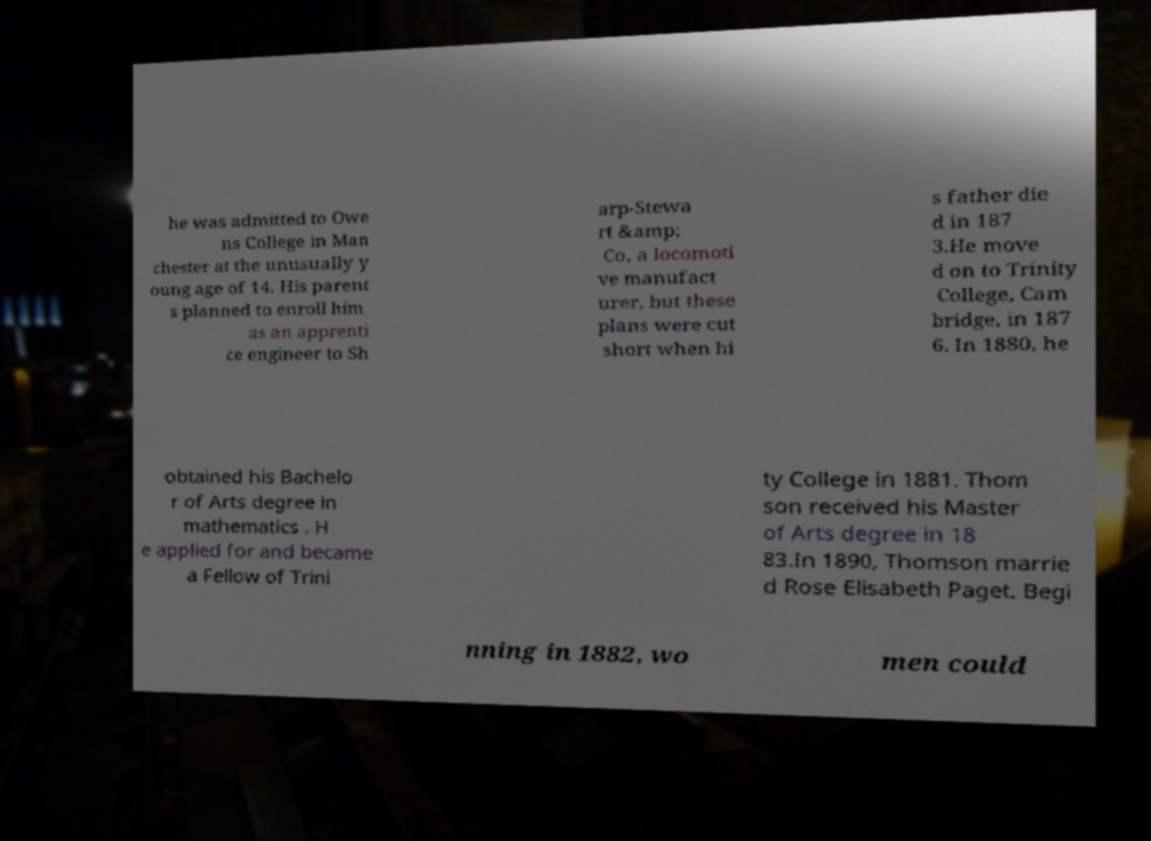Could you assist in decoding the text presented in this image and type it out clearly? he was admitted to Owe ns College in Man chester at the unusually y oung age of 14. His parent s planned to enroll him as an apprenti ce engineer to Sh arp-Stewa rt &amp; Co, a locomoti ve manufact urer, but these plans were cut short when hi s father die d in 187 3.He move d on to Trinity College, Cam bridge, in 187 6. In 1880, he obtained his Bachelo r of Arts degree in mathematics . H e applied for and became a Fellow of Trini ty College in 1881. Thom son received his Master of Arts degree in 18 83.In 1890, Thomson marrie d Rose Elisabeth Paget. Begi nning in 1882, wo men could 